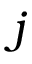Convert formula to latex. <formula><loc_0><loc_0><loc_500><loc_500>j</formula> 